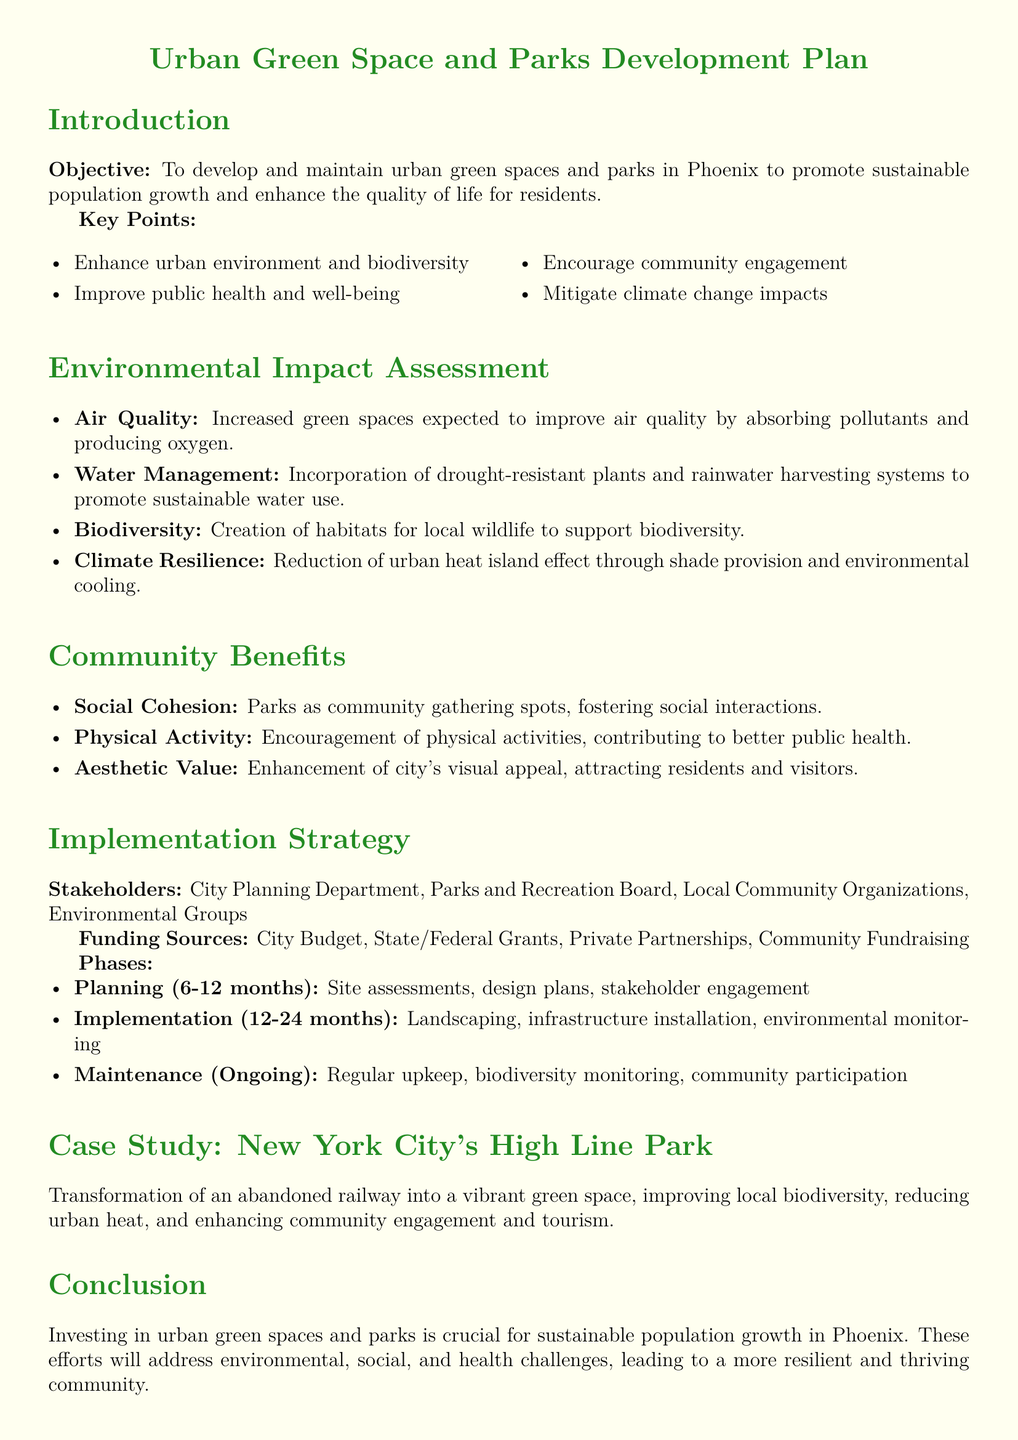What is the objective of the Urban Green Space and Parks Development Plan? The objective is to develop and maintain urban green spaces and parks in Phoenix to promote sustainable population growth and enhance the quality of life for residents.
Answer: To develop and maintain urban green spaces and parks in Phoenix to promote sustainable population growth and enhance the quality of life for residents How many phases are outlined in the implementation strategy? The implementation strategy includes three phases: Planning, Implementation, and Maintenance.
Answer: Three phases What specific case study is mentioned in the document? The document references New York City's High Line Park as a successful case study related to urban green space development.
Answer: New York City's High Line Park What is one of the benefits of increased green spaces on air quality? Increased green spaces are expected to improve air quality by absorbing pollutants and producing oxygen.
Answer: Improve air quality by absorbing pollutants and producing oxygen Who are the stakeholders involved in the implementation strategy? The document identifies the City Planning Department, Parks and Recreation Board, Local Community Organizations, and Environmental Groups as key stakeholders.
Answer: City Planning Department, Parks and Recreation Board, Local Community Organizations, Environmental Groups What is one of the community benefits listed for parks? One of the benefits mentioned is encouraging physical activities for better public health.
Answer: Encouragement of physical activities What type of funding sources is included in the plan? The funding sources for the plan include City Budget, State/Federal Grants, Private Partnerships, and Community Fundraising.
Answer: City Budget, State/Federal Grants, Private Partnerships, Community Fundraising What is a proposed method for water management in green spaces? The plan includes incorporation of drought-resistant plants and rainwater harvesting systems to promote sustainable water use.
Answer: Incorporation of drought-resistant plants and rainwater harvesting systems What environmental benefit reduces the urban heat island effect? The document notes that the reduction of the urban heat island effect is achieved through shade provision and environmental cooling.
Answer: Reduction of urban heat island effect through shade provision and environmental cooling 